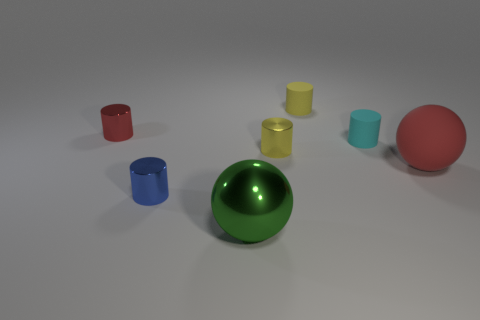Subtract 2 cylinders. How many cylinders are left? 3 Subtract all tiny yellow metallic cylinders. How many cylinders are left? 4 Subtract all blue cylinders. How many cylinders are left? 4 Add 1 tiny metallic cylinders. How many objects exist? 8 Subtract all green cylinders. Subtract all cyan spheres. How many cylinders are left? 5 Subtract all balls. How many objects are left? 5 Subtract 0 brown balls. How many objects are left? 7 Subtract all tiny metallic objects. Subtract all matte things. How many objects are left? 1 Add 4 cylinders. How many cylinders are left? 9 Add 7 gray metallic objects. How many gray metallic objects exist? 7 